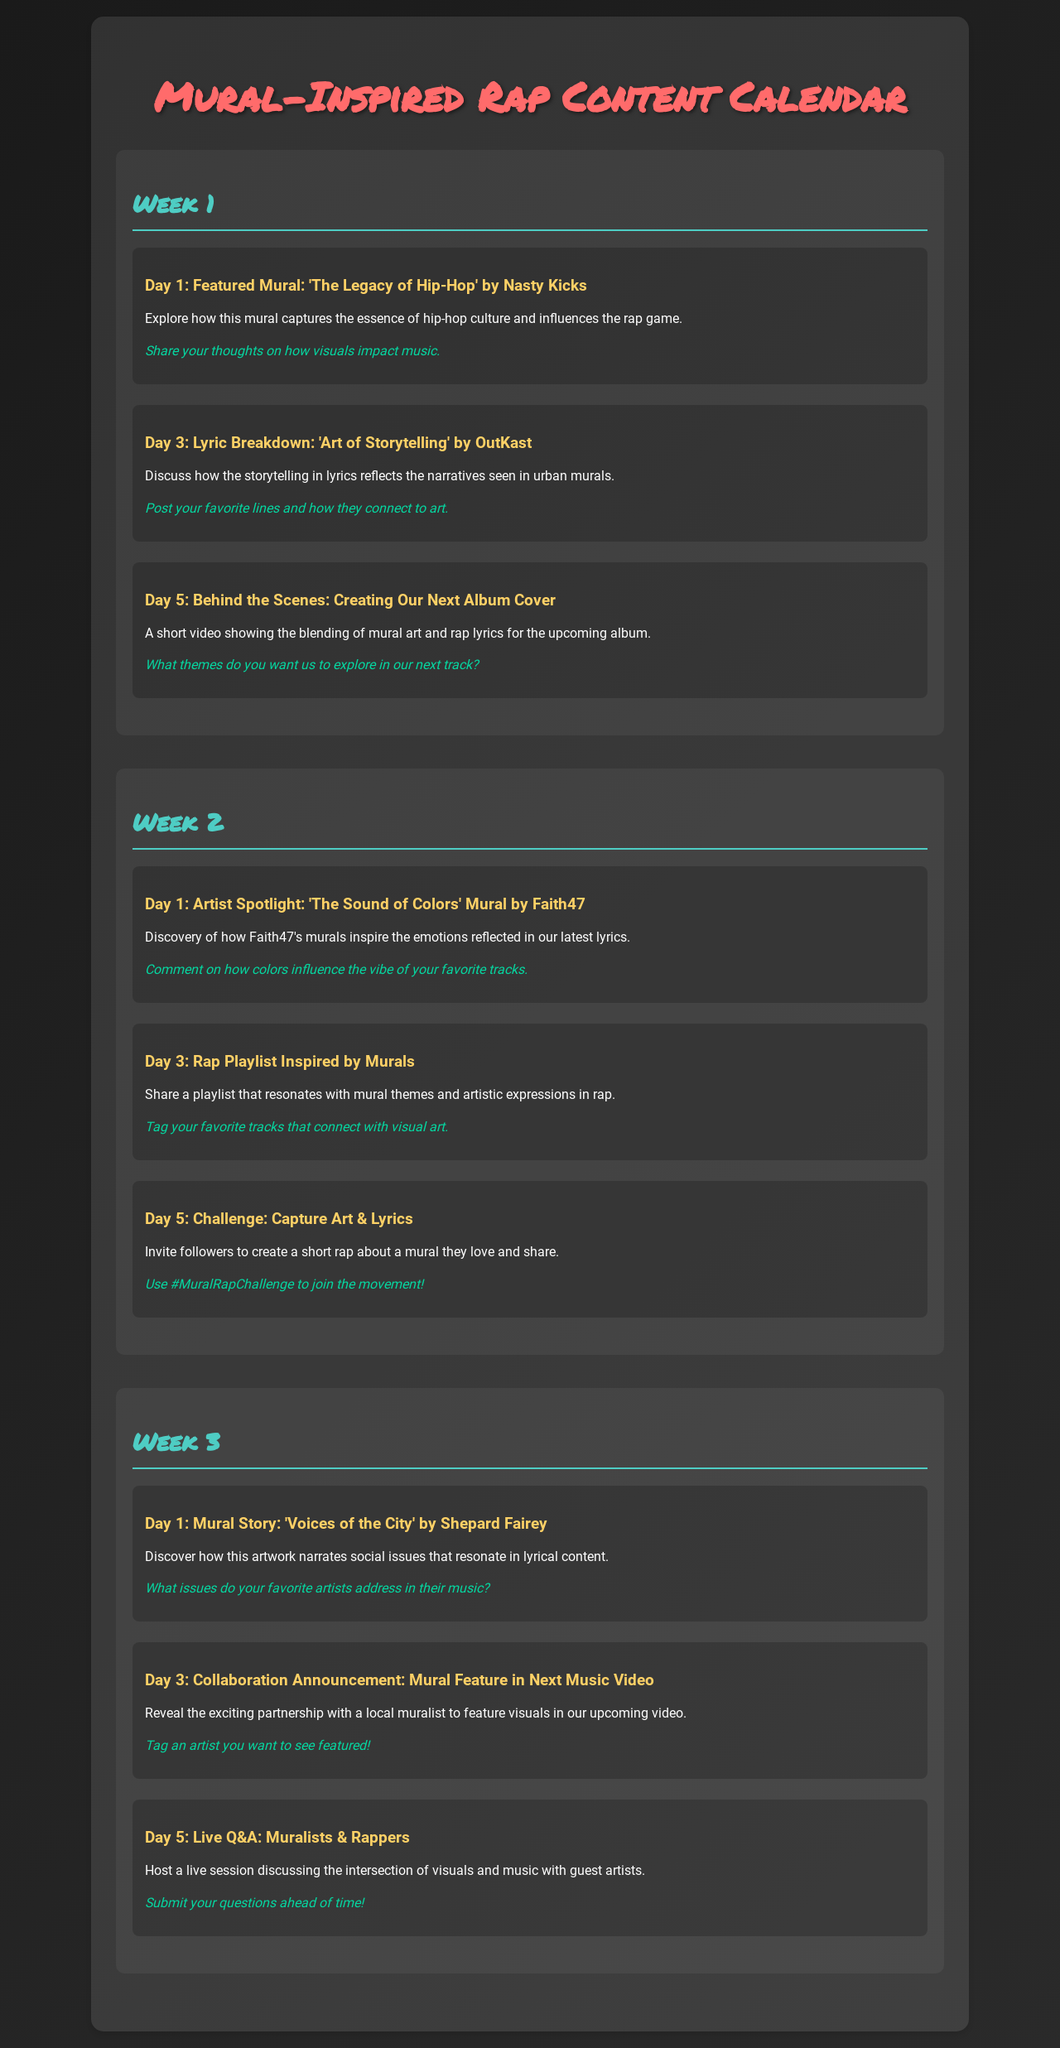What is the title of the document? The title is prominently displayed at the top of the document, indicating the theme of the content calendar.
Answer: Mural-Inspired Rap Content Calendar Who is the artist of the mural 'The Legacy of Hip-Hop'? This information is found in the Day 1 section of Week 1, which credits Nasty Kicks with the mural.
Answer: Nasty Kicks What is the date for the Lyric Breakdown in Week 1? The document outlines specific days for each activity; the Lyric Breakdown is scheduled for Day 3 of Week 1.
Answer: Day 3 What is the name of the artist featured on Day 1 of Week 2? The content for Day 1 of Week 2 introduces Faith47 as the artist of 'The Sound of Colors' mural.
Answer: Faith47 On which day is the live Q&A scheduled in Week 3? The document specifies that the live Q&A is set for Day 5 of Week 3.
Answer: Day 5 What is the challenge introduced on Day 5 of Week 2? This day features a creative challenge, encouraging followers to engage by creating and sharing their own content.
Answer: Capture Art & Lyrics How many days are outlined in each week of the content calendar? Each week in the document contains three unique days of scheduled content.
Answer: Three days 